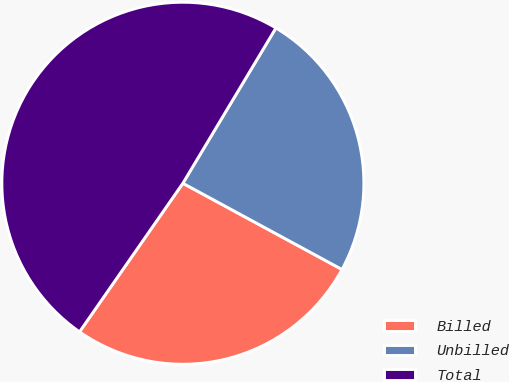Convert chart. <chart><loc_0><loc_0><loc_500><loc_500><pie_chart><fcel>Billed<fcel>Unbilled<fcel>Total<nl><fcel>26.77%<fcel>24.31%<fcel>48.92%<nl></chart> 